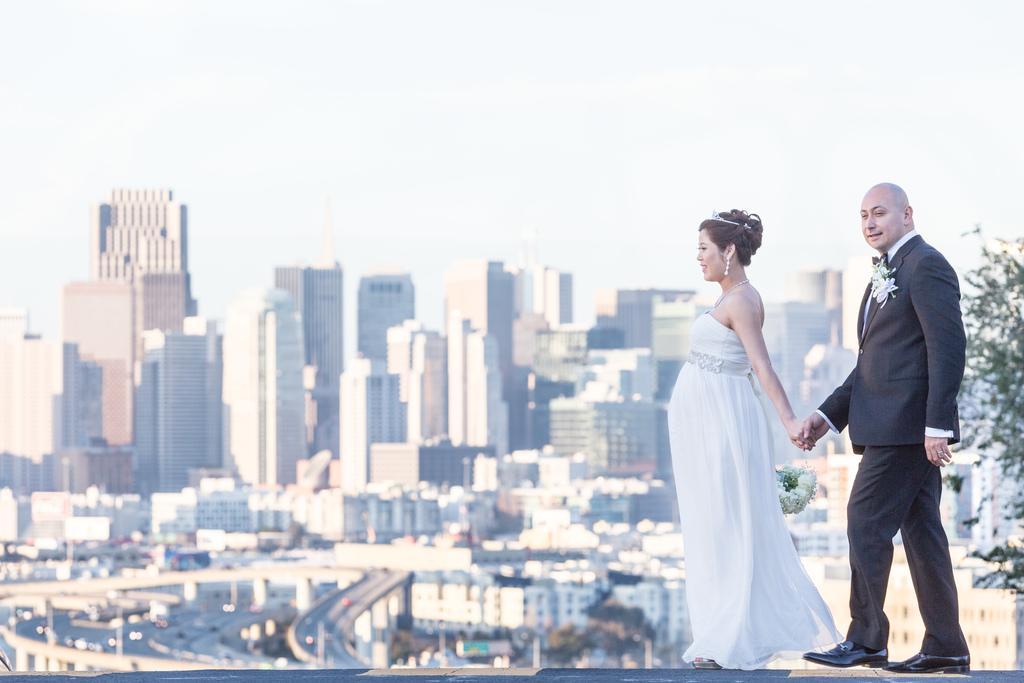How many people are present in the image? There is a man and a woman present in the image. What type of structures can be seen in the image? There are buildings in the image. What other natural elements are visible in the image? There are trees in the image. What type of man-made structures are present for transportation? There are roads and vehicles in the image. What type of advertising or signage is present in the image? There are hoardings in the image. What can be seen in the background of the image? The sky is visible in the background of the image. What type of approval is required for the downtown jam in the image? There is no mention of a downtown jam or any approval process in the image. 